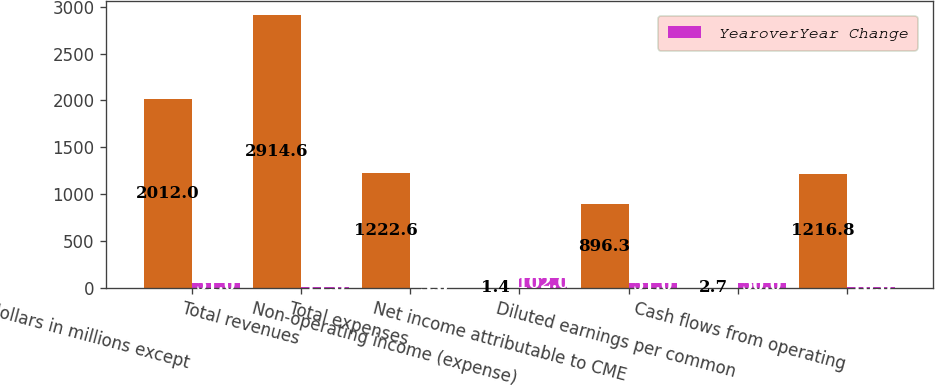<chart> <loc_0><loc_0><loc_500><loc_500><stacked_bar_chart><ecel><fcel>(dollars in millions except<fcel>Total revenues<fcel>Total expenses<fcel>Non-operating income (expense)<fcel>Net income attributable to CME<fcel>Diluted earnings per common<fcel>Cash flows from operating<nl><fcel>nan<fcel>2012<fcel>2914.6<fcel>1222.6<fcel>1.4<fcel>896.3<fcel>2.7<fcel>1216.8<nl><fcel>YearoverYear Change<fcel>51<fcel>11<fcel>3<fcel>102<fcel>51<fcel>50<fcel>10<nl></chart> 